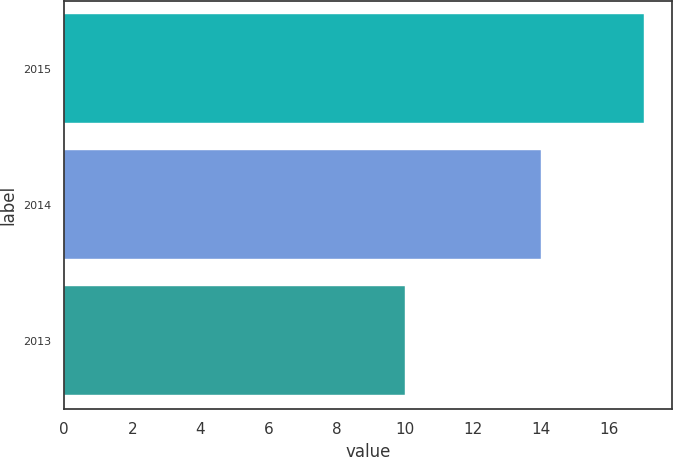Convert chart to OTSL. <chart><loc_0><loc_0><loc_500><loc_500><bar_chart><fcel>2015<fcel>2014<fcel>2013<nl><fcel>17<fcel>14<fcel>10<nl></chart> 